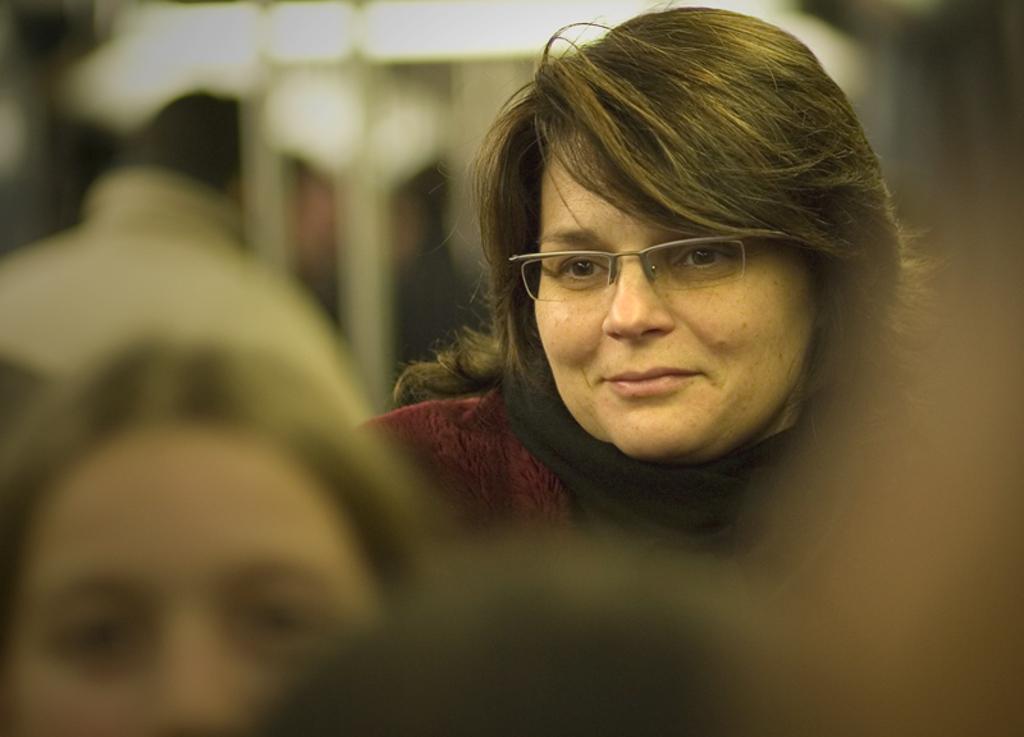How would you summarize this image in a sentence or two? In this image I can see a person wearing maroon color dress and wearing a spectacles, in front I can see the other person standing and I can see blurred background. 